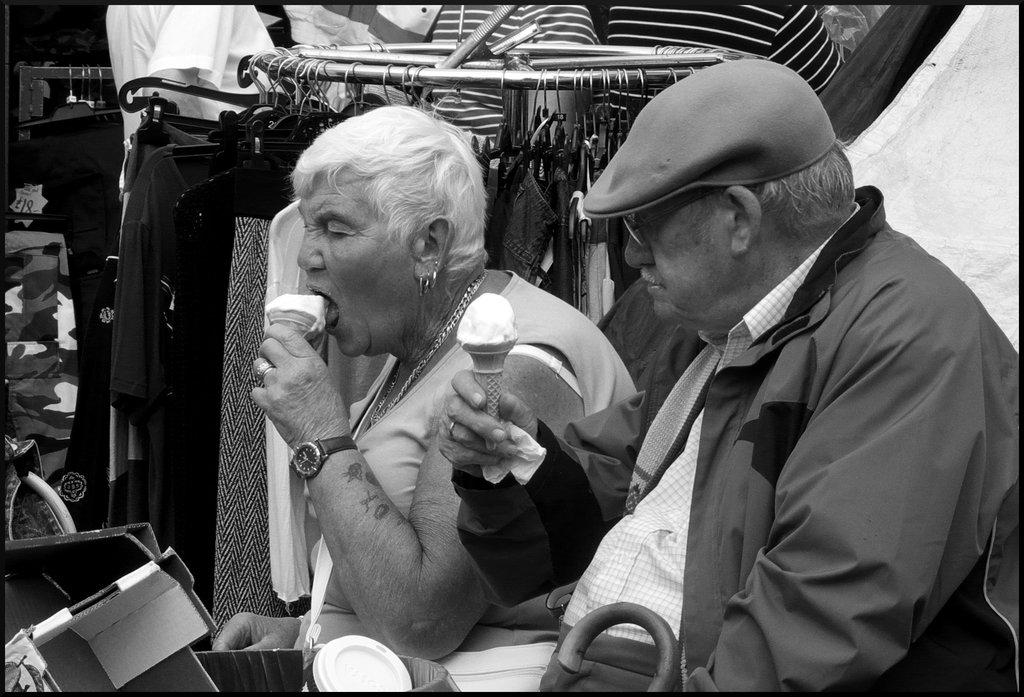How many people are present in the image? There are two persons sitting in the image. What are the persons holding in the image? The persons are holding ice creams. What can be seen in the background of the image? There is a cloth stand in the background of the image. What is on the cloth stand? Clothes are hanged on the cloth stand. What type of corn is being used as a decoration on the table in the image? There is no corn present in the image; it features two persons holding ice creams and a cloth stand with clothes in the background. 